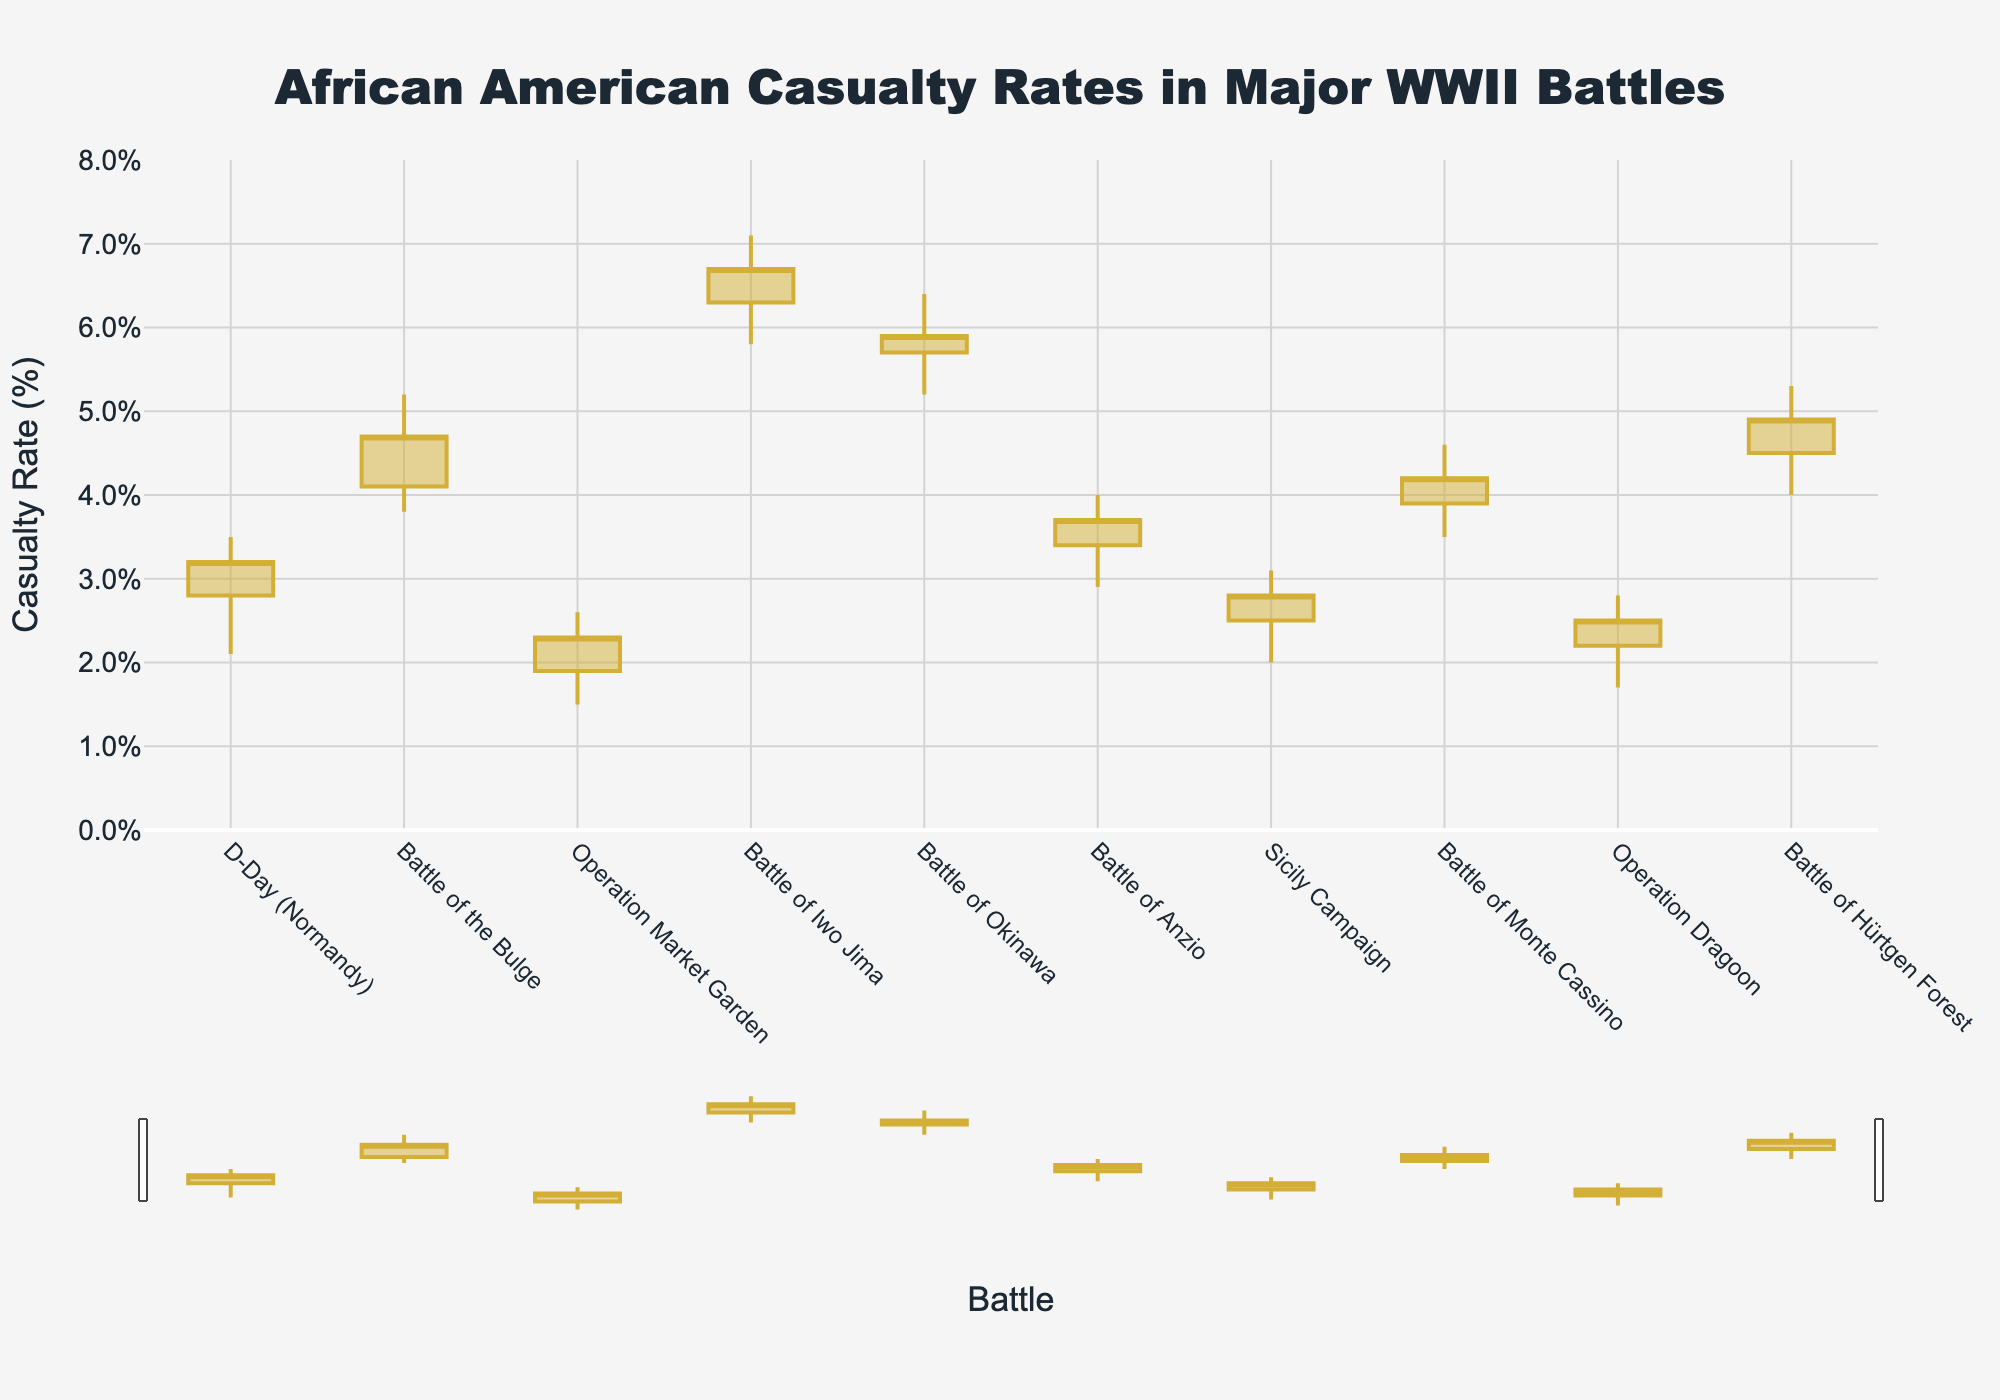how many battles are presented in the figure? Count the distinct battles listed on the x-axis. These battles are represented by separate candlestick bars.
Answer: 10 Which battle has the highest recorded casualty rate? Look for the highest point on the vertical axis (High value) among all candlesticks. The Battle of Iwo Jima has the highest peak at 7.1%.
Answer: Battle of Iwo Jima What is the lowest casualty rate recorded in the Battle of the Bulge? Identify the lowest point on the candlestick for the Battle of the Bulge. It reaches down to 3.8%.
Answer: 3.8% Which battle shows the smallest difference between High and Low casualty rates? Calculate the range (High - Low) for each battle's candlestick. Operation Market Garden has the smallest difference: 2.6% - 1.5% = 1.1%.
Answer: Operation Market Garden How does the open rate of the Battle of Monte Cassino compare to its close rate? Compare the open and close rates for the Battle of Monte Cassino. Open is 3.9% and close is 4.2%, so the close rate is higher.
Answer: Close rate is higher What is the mean casualty rate for the Battle of Hürtgen Forest considering Open, High, Low, and Close? Add all four rates for the Battle of Hürtgen Forest and divide by 4: (4.5 + 5.3 + 4.0 + 4.9) / 4 = 4.675%.
Answer: 4.675% Between D-Day (Normandy) and Sicily Campaign, which battle had a higher open casualty rate? Compare the open rates directly from the chart. D-Day (Normandy) has an open rate of 2.8%, and Sicily Campaign has 2.5%.
Answer: D-Day (Normandy) Is the closing rate for the Battle of Anzio greater than the opening rate for Operation Dragoon? Compare the close rate of the Battle of Anzio (3.7%) with the open rate of Operation Dragoon (2.2%).
Answer: Yes Considering the data for all battles, which event shows the most significant drop from High to Low casualty rates? Evaluate the drop (High - Low) for each event. The Battle of Iwo Jima has the largest drop of 7.1% - 5.8% = 1.3%.
Answer: Battle of Iwo Jima Which battles have a closing rate higher than their opening rate? Check the closing and opening values for each battle and list those where the closing rate exceeds the opening rate. These are D-Day (Normandy), Battle of the Bulge, Battle of Iwo Jima, Battle of Anzio, Battle of Monte Cassino, and Battle of Hürtgen Forest.
Answer: D-Day (Normandy), Battle of the Bulge, Battle of Iwo Jima, Battle of Anzio, Battle of Monte Cassino, Battle of Hürtgen Forest 